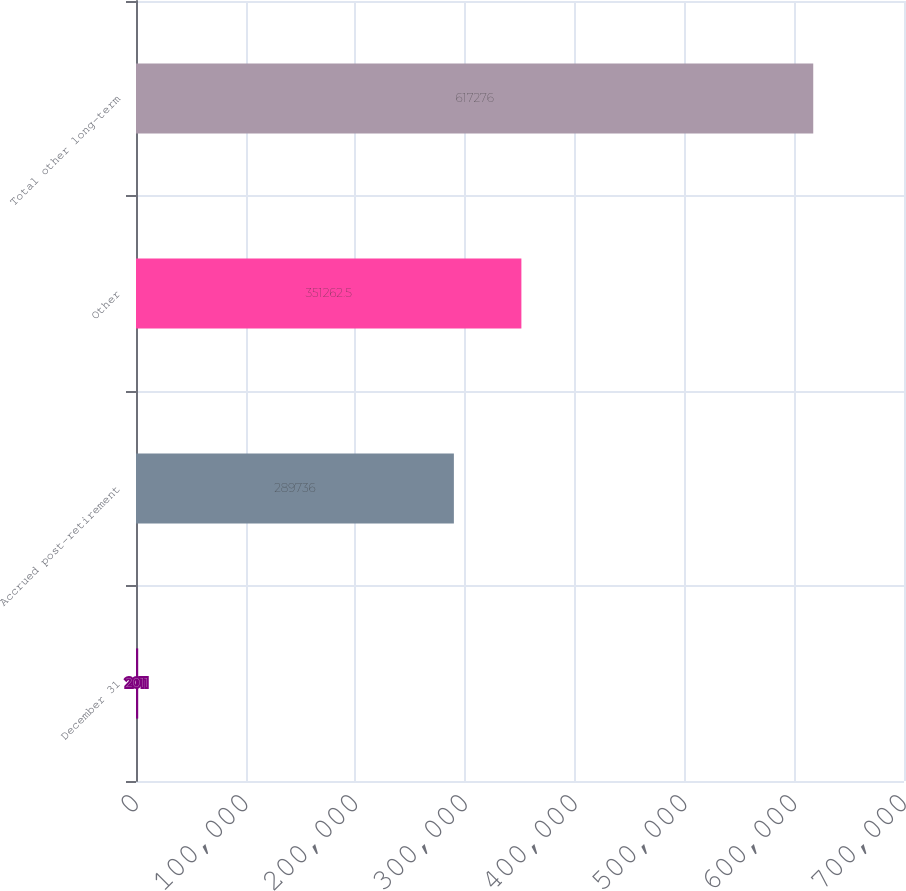<chart> <loc_0><loc_0><loc_500><loc_500><bar_chart><fcel>December 31<fcel>Accrued post-retirement<fcel>Other<fcel>Total other long-term<nl><fcel>2011<fcel>289736<fcel>351262<fcel>617276<nl></chart> 